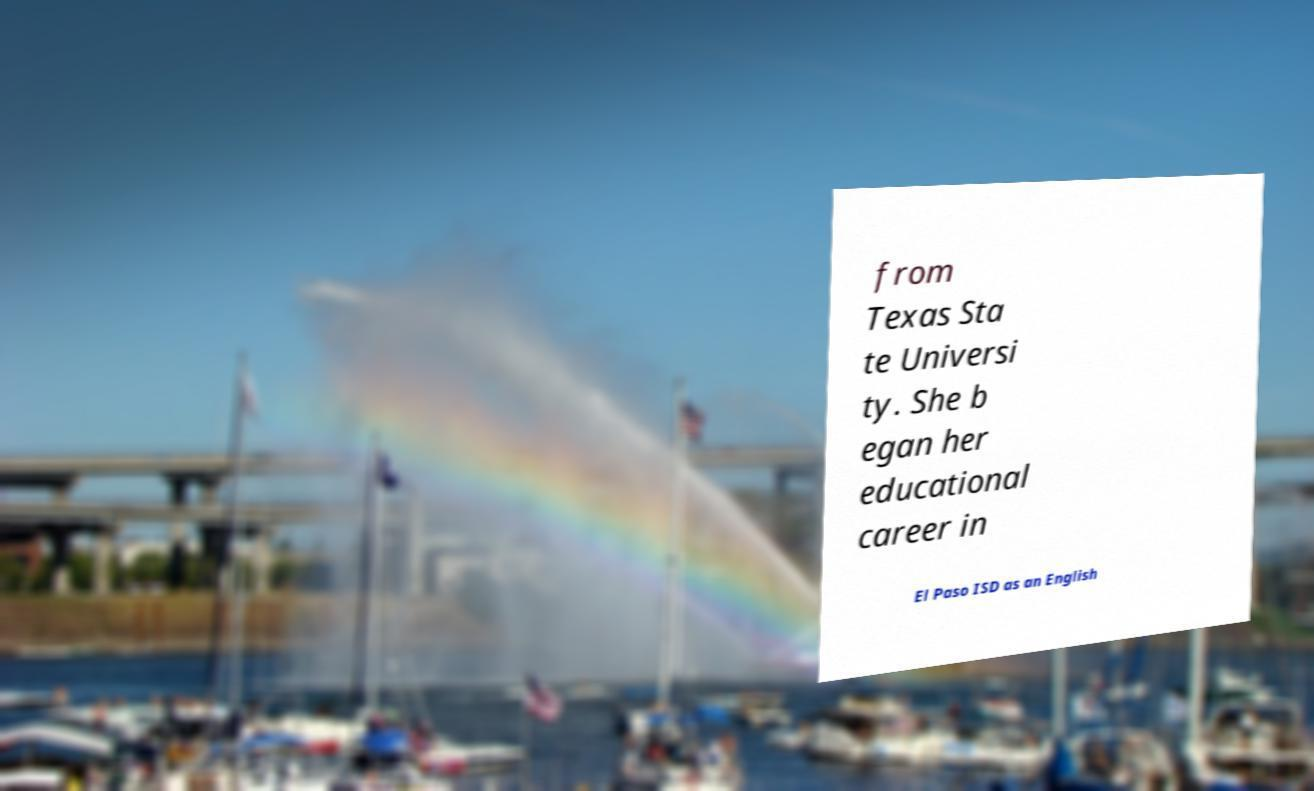Can you accurately transcribe the text from the provided image for me? from Texas Sta te Universi ty. She b egan her educational career in El Paso ISD as an English 